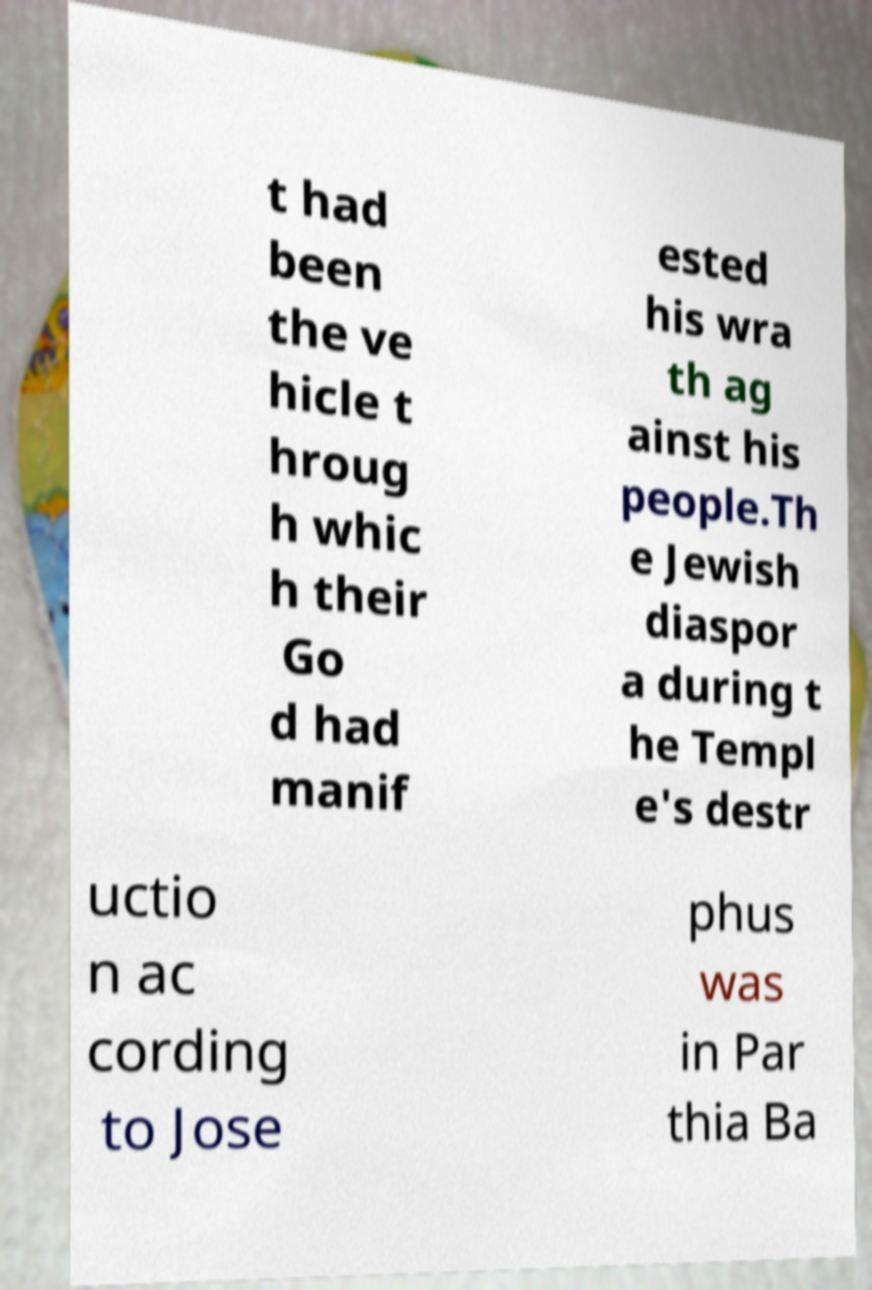Can you accurately transcribe the text from the provided image for me? t had been the ve hicle t hroug h whic h their Go d had manif ested his wra th ag ainst his people.Th e Jewish diaspor a during t he Templ e's destr uctio n ac cording to Jose phus was in Par thia Ba 